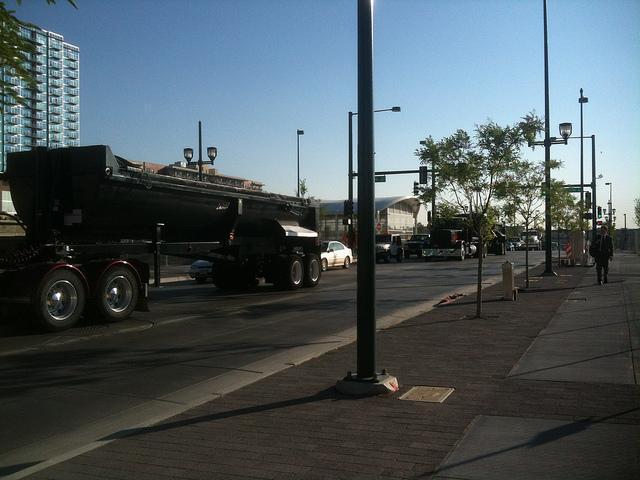How many trucks are in the picture?
Give a very brief answer. 1. How many bikes are driving down the street?
Give a very brief answer. 0. 